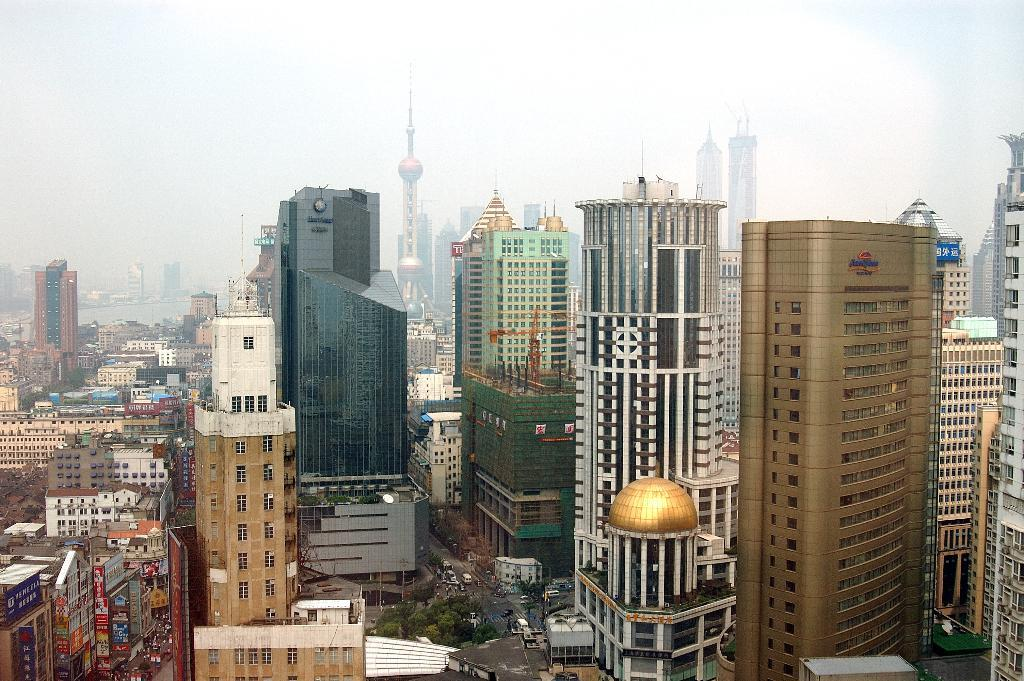What type of structures can be seen in the image? There are many buildings and towers in the image. Are there any natural elements present in the image? There are few trees in the image. What else can be seen in the image besides buildings and trees? There are vehicles in the image. What can be seen in the background on the left side of the image? In the background, there appears to be a water surface on the left side. What type of bells can be heard ringing in the image? There are no bells present in the image, and therefore no sound can be heard. 